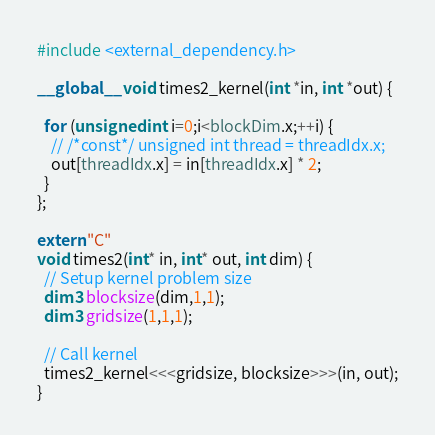Convert code to text. <code><loc_0><loc_0><loc_500><loc_500><_Cuda_>
#include <external_dependency.h>

__global__ void times2_kernel(int *in, int *out) {

  for (unsigned int i=0;i<blockDim.x;++i) {
    // /*const*/ unsigned int thread = threadIdx.x;
    out[threadIdx.x] = in[threadIdx.x] * 2;
  }
};

extern "C"
void times2(int* in, int* out, int dim) {
  // Setup kernel problem size
  dim3 blocksize(dim,1,1);
  dim3 gridsize(1,1,1);

  // Call kernel
  times2_kernel<<<gridsize, blocksize>>>(in, out);
}

</code> 